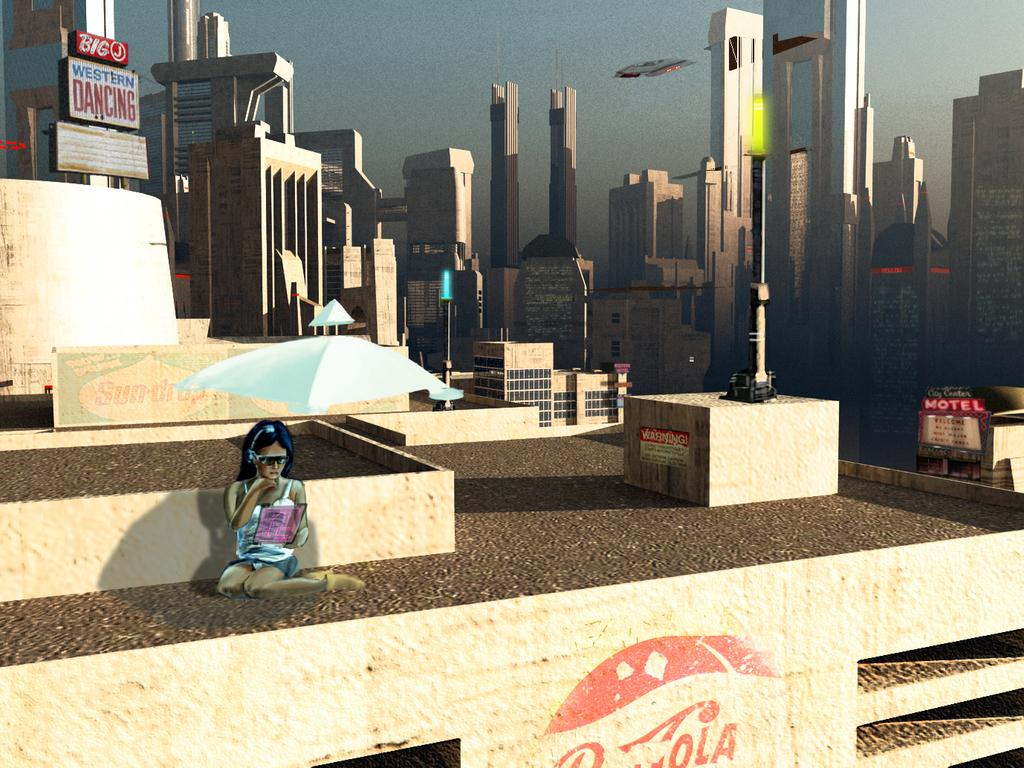What is the girl in the image doing? The girl is sitting on the ground in the image. What can be seen in the background of the image? Buildings are visible in the image. What type of signs are present in the image? Name boards are present in the image. What structures are holding lights in the image? Poles with lights are in the image. What other objects can be seen in the image? There are other objects in the image, but their specific details are not mentioned in the provided facts. What is visible in the sky in the image? The sky is visible in the background of the image. What type of sweater is the girl wearing in the image? There is no mention of a sweater in the provided facts, so it cannot be determined what type of sweater the girl is wearing. 